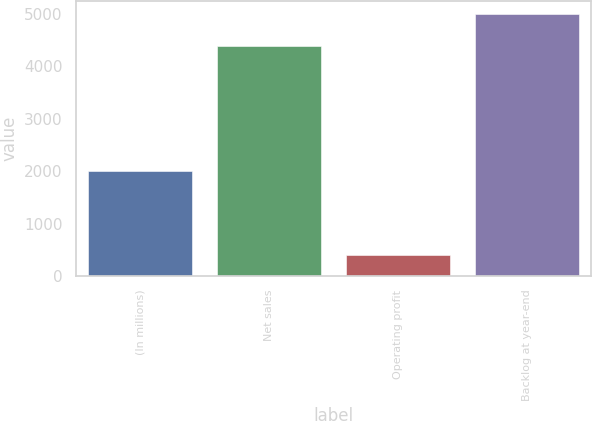<chart> <loc_0><loc_0><loc_500><loc_500><bar_chart><fcel>(In millions)<fcel>Net sales<fcel>Operating profit<fcel>Backlog at year-end<nl><fcel>2006<fcel>4387<fcel>405<fcel>4999<nl></chart> 